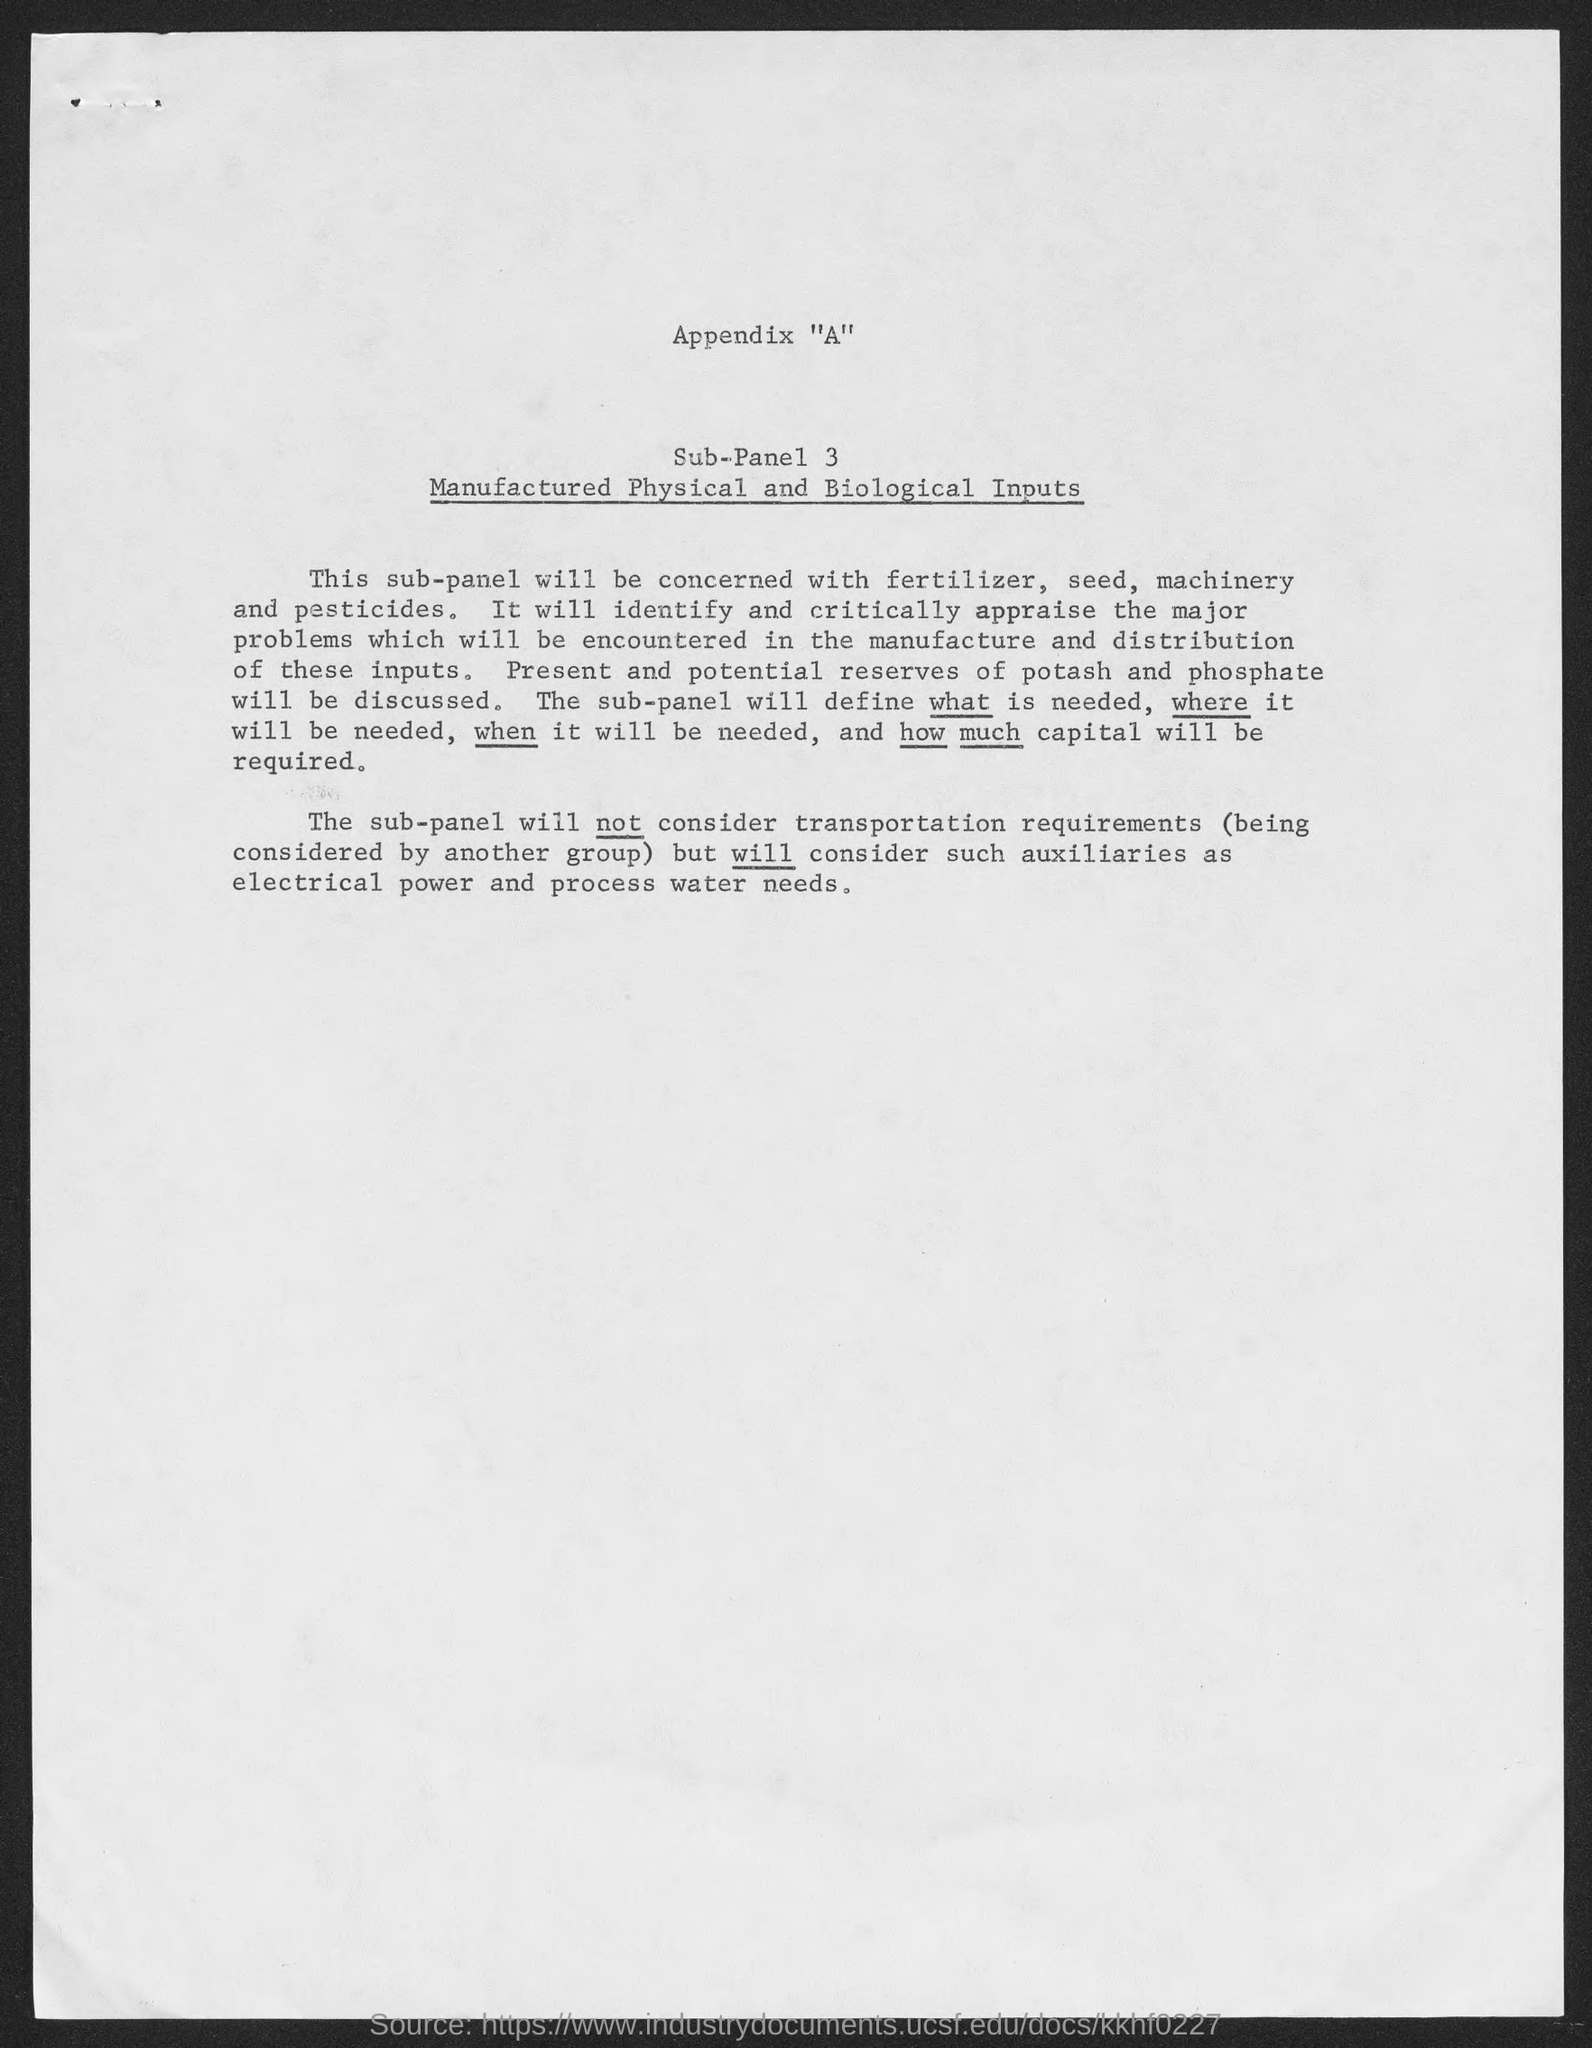Specify some key components in this picture. The title of sub-panel 3 is "Manufactured Physical and Biological Inputs. 